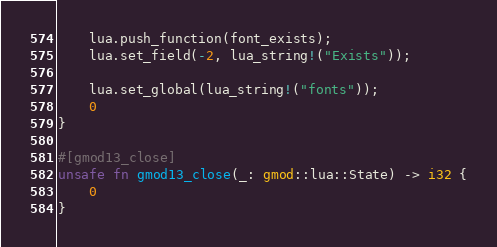<code> <loc_0><loc_0><loc_500><loc_500><_Rust_>
	lua.push_function(font_exists);
	lua.set_field(-2, lua_string!("Exists"));

	lua.set_global(lua_string!("fonts"));
    0
}

#[gmod13_close]
unsafe fn gmod13_close(_: gmod::lua::State) -> i32 {
    0
}</code> 